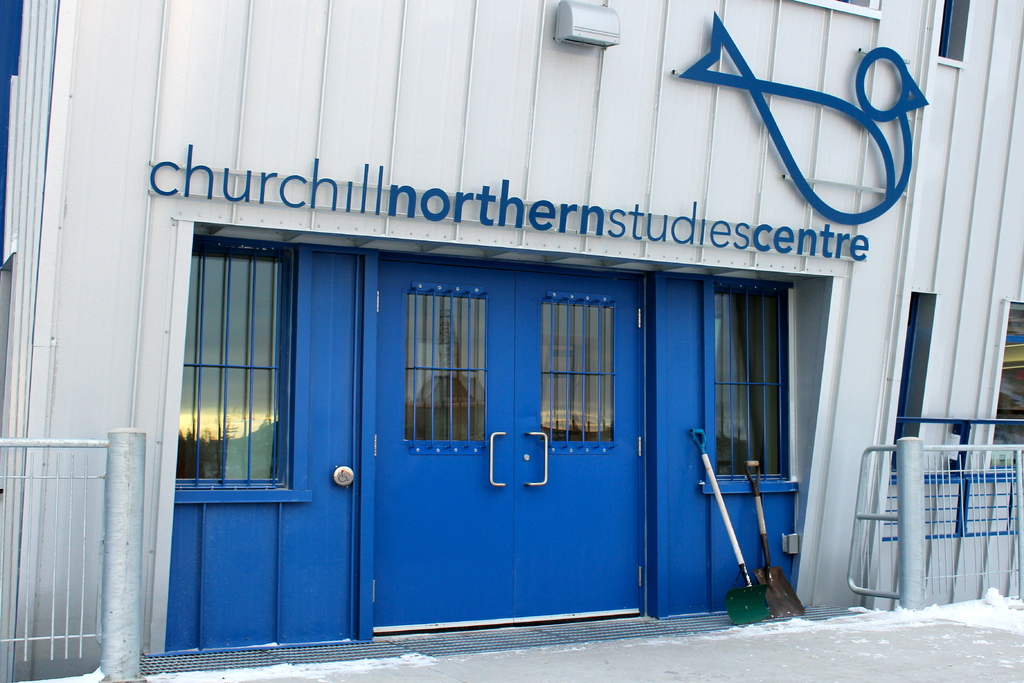Can you tell me more about the architectural design of the building? The building's design is utilitarian and robust, tailored to withstand the severe weather conditions typical of Manitoba's northern region. The structure's white walls and gray roof help to reflect sunlight and retain warmth. Security bars on the windows and insulated double doors are practical features that enhance the building's functionality in extreme weather, providing security and thermal efficiency. 